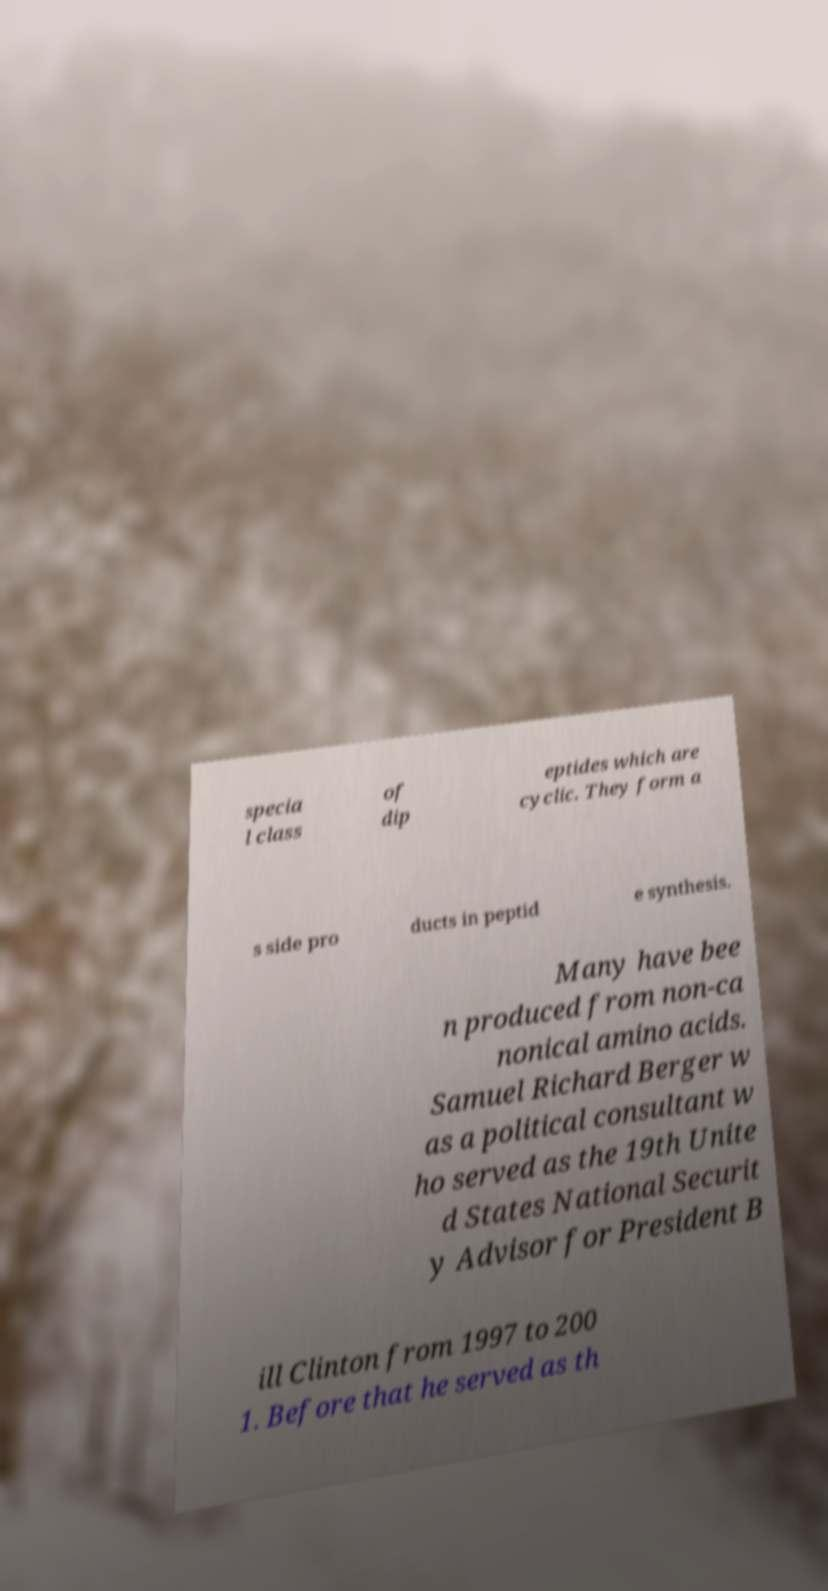What messages or text are displayed in this image? I need them in a readable, typed format. specia l class of dip eptides which are cyclic. They form a s side pro ducts in peptid e synthesis. Many have bee n produced from non-ca nonical amino acids. Samuel Richard Berger w as a political consultant w ho served as the 19th Unite d States National Securit y Advisor for President B ill Clinton from 1997 to 200 1. Before that he served as th 